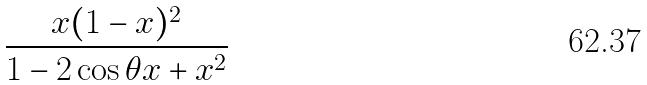<formula> <loc_0><loc_0><loc_500><loc_500>\frac { x ( 1 - x ) ^ { 2 } } { 1 - 2 \cos \theta x + x ^ { 2 } }</formula> 